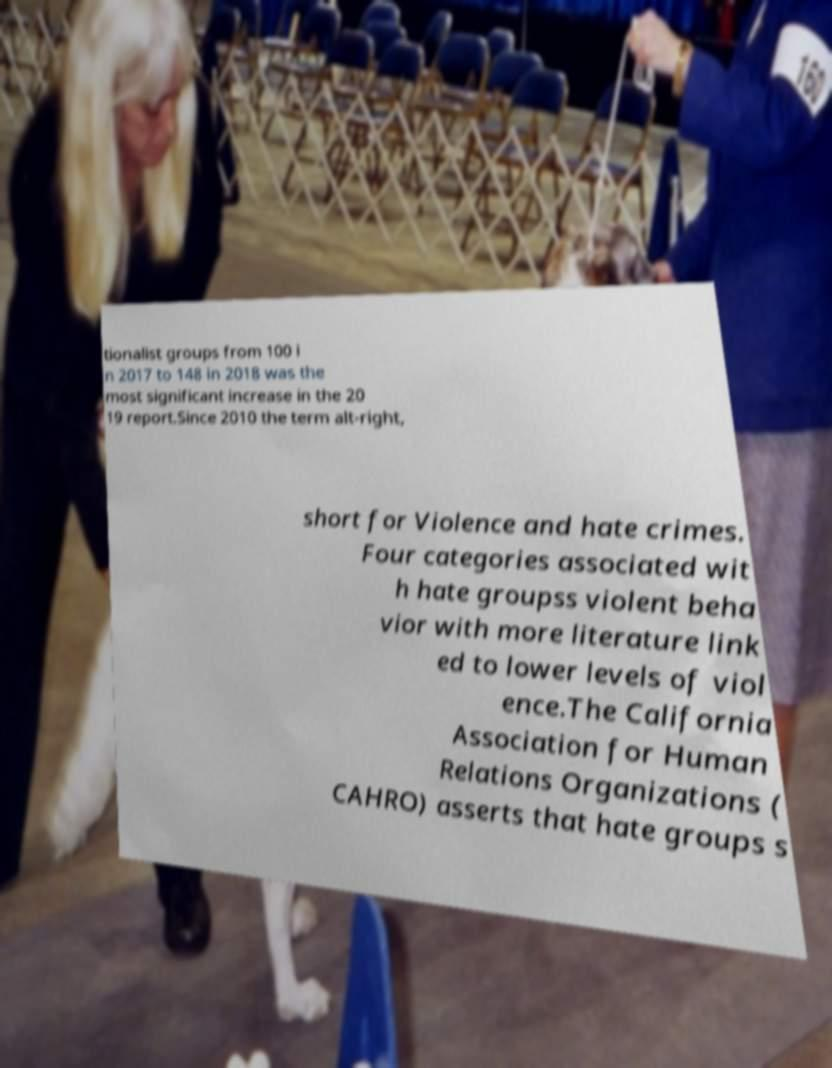For documentation purposes, I need the text within this image transcribed. Could you provide that? tionalist groups from 100 i n 2017 to 148 in 2018 was the most significant increase in the 20 19 report.Since 2010 the term alt-right, short for Violence and hate crimes. Four categories associated wit h hate groupss violent beha vior with more literature link ed to lower levels of viol ence.The California Association for Human Relations Organizations ( CAHRO) asserts that hate groups s 